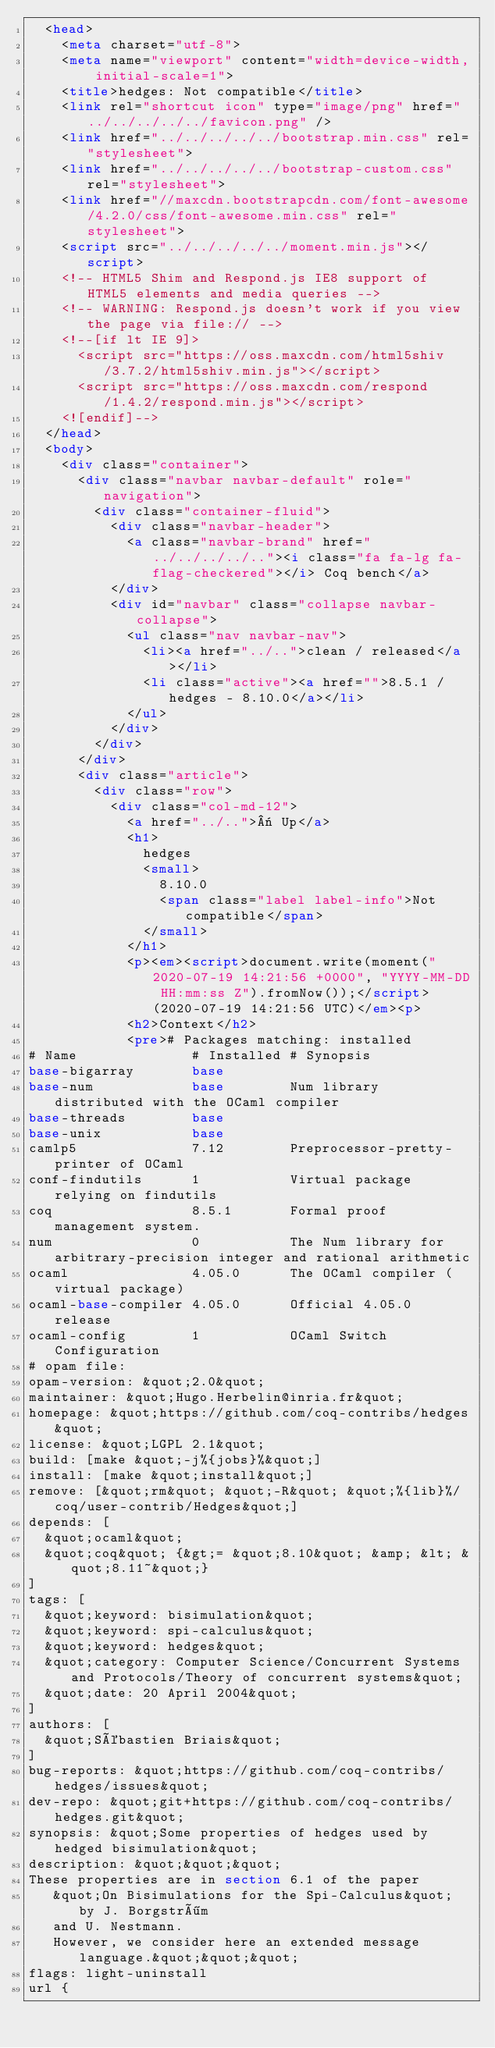<code> <loc_0><loc_0><loc_500><loc_500><_HTML_>  <head>
    <meta charset="utf-8">
    <meta name="viewport" content="width=device-width, initial-scale=1">
    <title>hedges: Not compatible</title>
    <link rel="shortcut icon" type="image/png" href="../../../../../favicon.png" />
    <link href="../../../../../bootstrap.min.css" rel="stylesheet">
    <link href="../../../../../bootstrap-custom.css" rel="stylesheet">
    <link href="//maxcdn.bootstrapcdn.com/font-awesome/4.2.0/css/font-awesome.min.css" rel="stylesheet">
    <script src="../../../../../moment.min.js"></script>
    <!-- HTML5 Shim and Respond.js IE8 support of HTML5 elements and media queries -->
    <!-- WARNING: Respond.js doesn't work if you view the page via file:// -->
    <!--[if lt IE 9]>
      <script src="https://oss.maxcdn.com/html5shiv/3.7.2/html5shiv.min.js"></script>
      <script src="https://oss.maxcdn.com/respond/1.4.2/respond.min.js"></script>
    <![endif]-->
  </head>
  <body>
    <div class="container">
      <div class="navbar navbar-default" role="navigation">
        <div class="container-fluid">
          <div class="navbar-header">
            <a class="navbar-brand" href="../../../../.."><i class="fa fa-lg fa-flag-checkered"></i> Coq bench</a>
          </div>
          <div id="navbar" class="collapse navbar-collapse">
            <ul class="nav navbar-nav">
              <li><a href="../..">clean / released</a></li>
              <li class="active"><a href="">8.5.1 / hedges - 8.10.0</a></li>
            </ul>
          </div>
        </div>
      </div>
      <div class="article">
        <div class="row">
          <div class="col-md-12">
            <a href="../..">« Up</a>
            <h1>
              hedges
              <small>
                8.10.0
                <span class="label label-info">Not compatible</span>
              </small>
            </h1>
            <p><em><script>document.write(moment("2020-07-19 14:21:56 +0000", "YYYY-MM-DD HH:mm:ss Z").fromNow());</script> (2020-07-19 14:21:56 UTC)</em><p>
            <h2>Context</h2>
            <pre># Packages matching: installed
# Name              # Installed # Synopsis
base-bigarray       base
base-num            base        Num library distributed with the OCaml compiler
base-threads        base
base-unix           base
camlp5              7.12        Preprocessor-pretty-printer of OCaml
conf-findutils      1           Virtual package relying on findutils
coq                 8.5.1       Formal proof management system.
num                 0           The Num library for arbitrary-precision integer and rational arithmetic
ocaml               4.05.0      The OCaml compiler (virtual package)
ocaml-base-compiler 4.05.0      Official 4.05.0 release
ocaml-config        1           OCaml Switch Configuration
# opam file:
opam-version: &quot;2.0&quot;
maintainer: &quot;Hugo.Herbelin@inria.fr&quot;
homepage: &quot;https://github.com/coq-contribs/hedges&quot;
license: &quot;LGPL 2.1&quot;
build: [make &quot;-j%{jobs}%&quot;]
install: [make &quot;install&quot;]
remove: [&quot;rm&quot; &quot;-R&quot; &quot;%{lib}%/coq/user-contrib/Hedges&quot;]
depends: [
  &quot;ocaml&quot;
  &quot;coq&quot; {&gt;= &quot;8.10&quot; &amp; &lt; &quot;8.11~&quot;}
]
tags: [
  &quot;keyword: bisimulation&quot;
  &quot;keyword: spi-calculus&quot;
  &quot;keyword: hedges&quot;
  &quot;category: Computer Science/Concurrent Systems and Protocols/Theory of concurrent systems&quot;
  &quot;date: 20 April 2004&quot;
]
authors: [
  &quot;Sébastien Briais&quot;
]
bug-reports: &quot;https://github.com/coq-contribs/hedges/issues&quot;
dev-repo: &quot;git+https://github.com/coq-contribs/hedges.git&quot;
synopsis: &quot;Some properties of hedges used by hedged bisimulation&quot;
description: &quot;&quot;&quot;
These properties are in section 6.1 of the paper
   &quot;On Bisimulations for the Spi-Calculus&quot; by J. Borgström
   and U. Nestmann.
   However, we consider here an extended message language.&quot;&quot;&quot;
flags: light-uninstall
url {</code> 